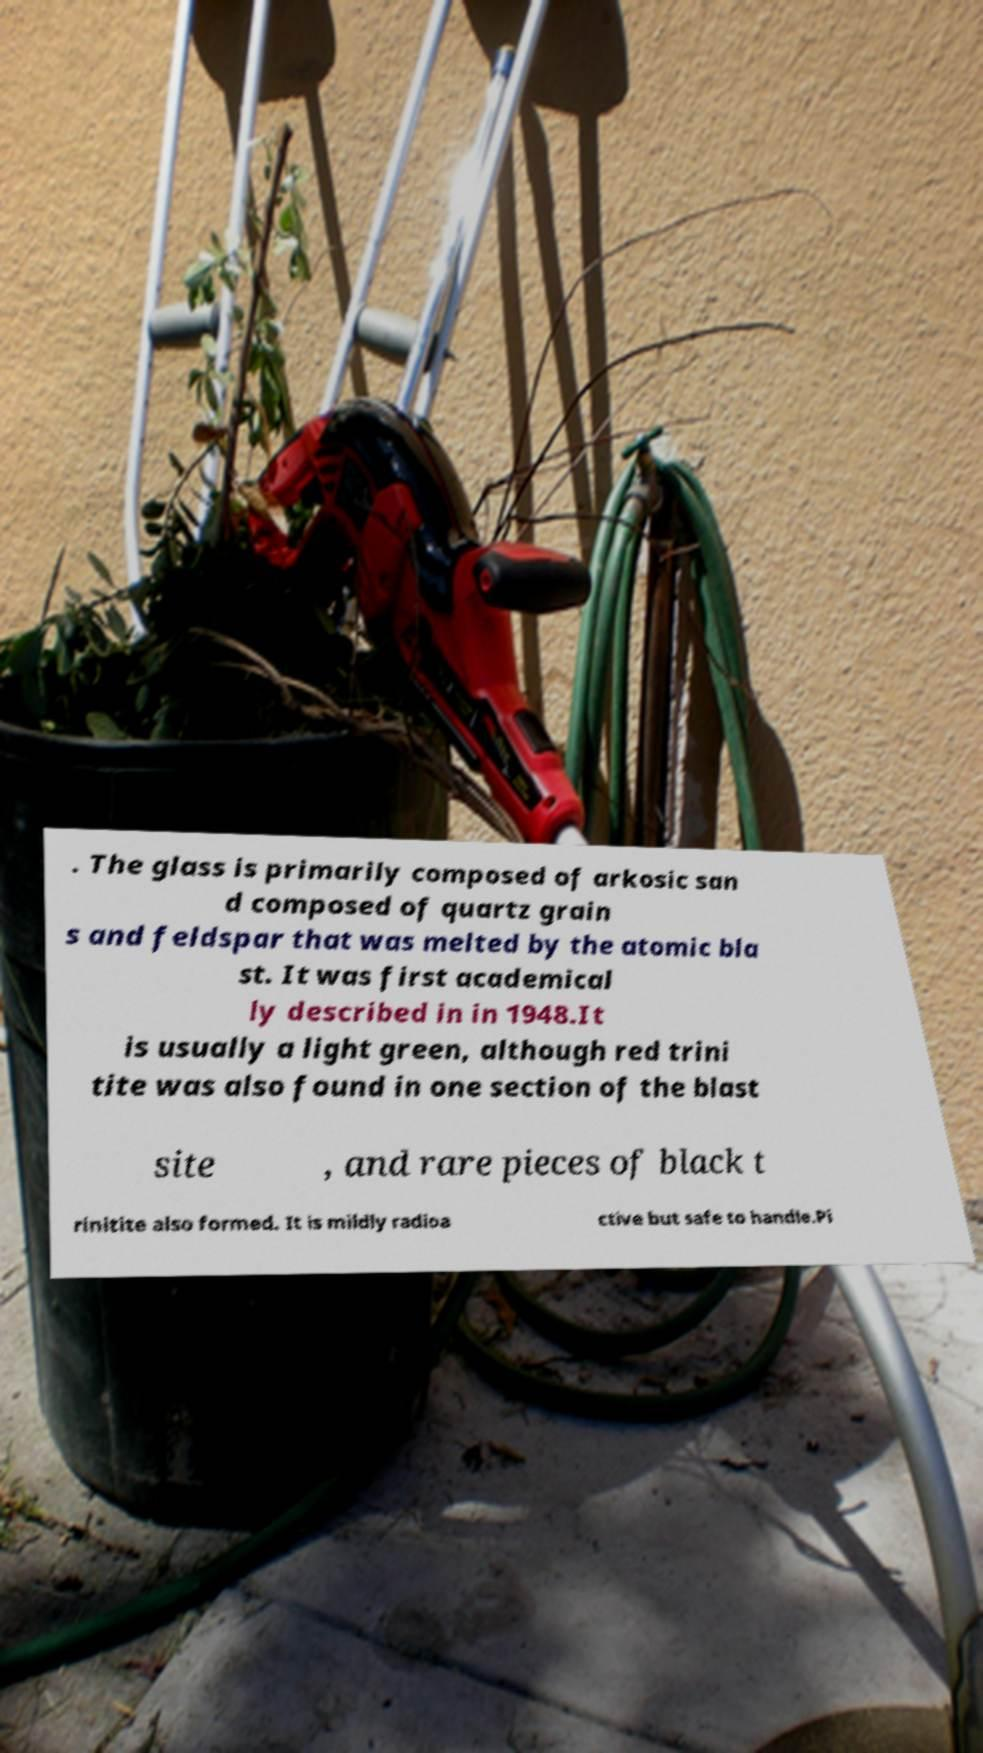For documentation purposes, I need the text within this image transcribed. Could you provide that? . The glass is primarily composed of arkosic san d composed of quartz grain s and feldspar that was melted by the atomic bla st. It was first academical ly described in in 1948.It is usually a light green, although red trini tite was also found in one section of the blast site , and rare pieces of black t rinitite also formed. It is mildly radioa ctive but safe to handle.Pi 